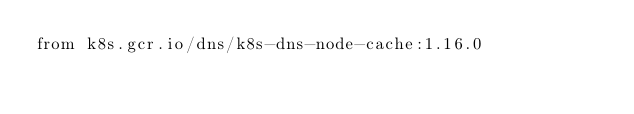Convert code to text. <code><loc_0><loc_0><loc_500><loc_500><_Dockerfile_>from k8s.gcr.io/dns/k8s-dns-node-cache:1.16.0
</code> 